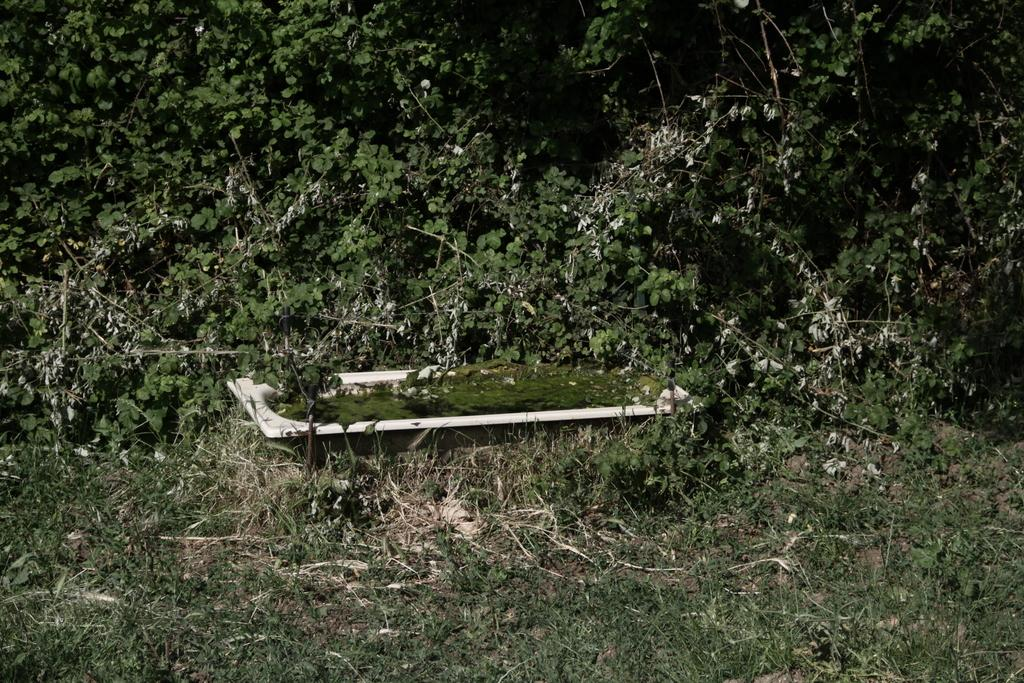What type of vegetation is visible in the image? There are trees in the image. What object might be used for bathing in the image? The image appears to depict a bathtub. What type of toothpaste is being used by the pig in the image? There is no pig or toothpaste present in the image. 